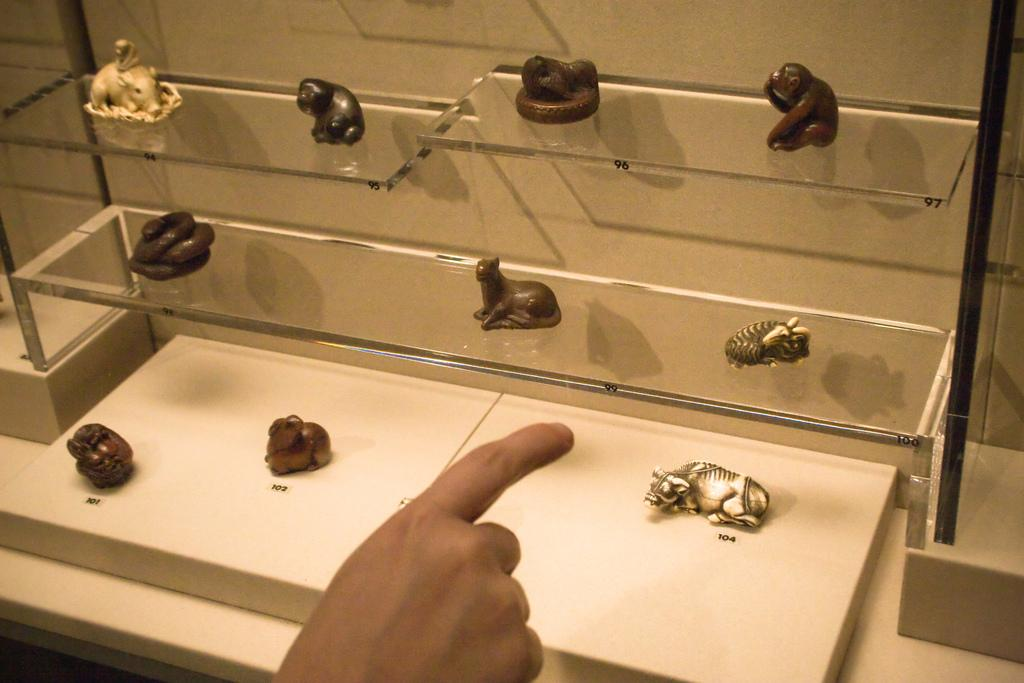What is the primary feature of the image? The primary feature of the image is objects on glass shelves. Can you describe any other elements in the image? Yes, a human hand is visible in the image. What type of background is present in the image? There is a wall in the image. What type of arch can be seen in the image? There is no arch present in the image. How many apples are on the glass shelves in the image? The provided facts do not mention the presence of apples in the image. 